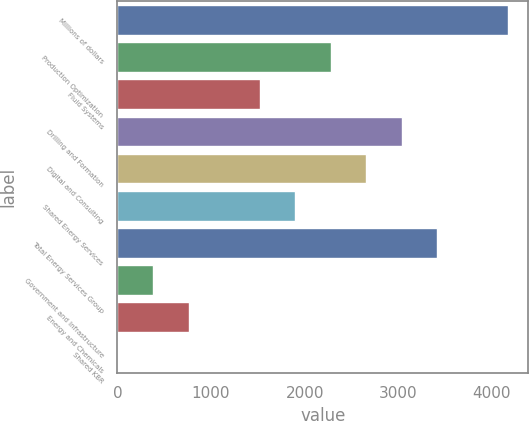<chart> <loc_0><loc_0><loc_500><loc_500><bar_chart><fcel>Millions of dollars<fcel>Production Optimization<fcel>Fluid Systems<fcel>Drilling and Formation<fcel>Digital and Consulting<fcel>Shared Energy Services<fcel>Total Energy Services Group<fcel>Government and Infrastructure<fcel>Energy and Chemicals<fcel>Shared KBR<nl><fcel>4175.5<fcel>2278<fcel>1519<fcel>3037<fcel>2657.5<fcel>1898.5<fcel>3416.5<fcel>380.5<fcel>760<fcel>1<nl></chart> 